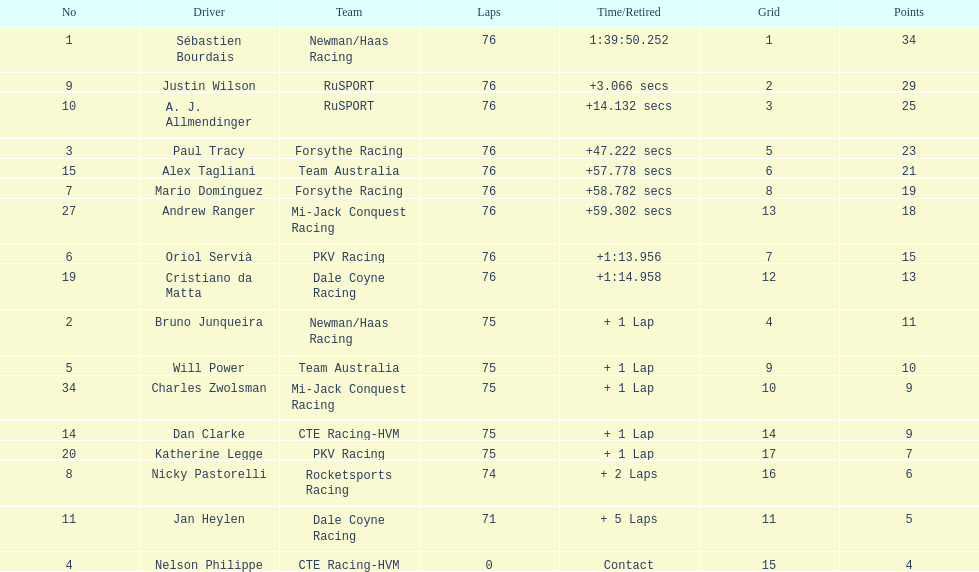Charles zwolsman acquired the same number of points as who? Dan Clarke. 